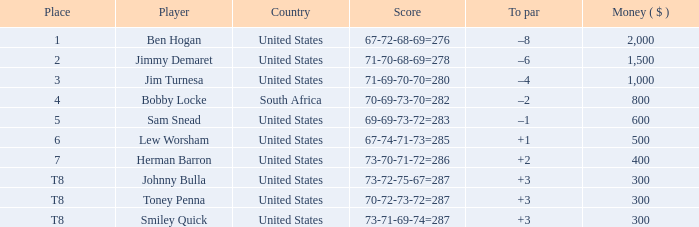What is the To par of the Player with a Score of 73-70-71-72=286? 2.0. 